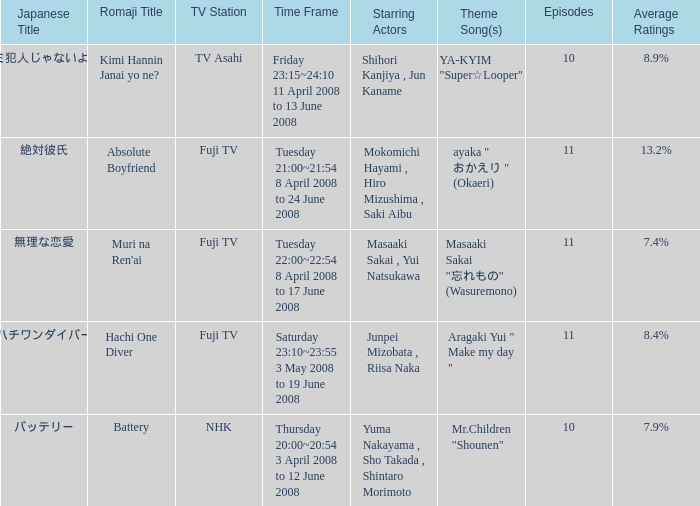Who were the initial performers during the period of tuesday 22:00~22:54 8 april 2008 to 17 june 2008? Masaaki Sakai , Yui Natsukawa. 